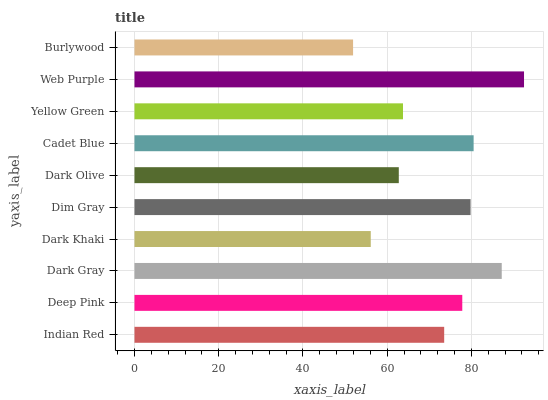Is Burlywood the minimum?
Answer yes or no. Yes. Is Web Purple the maximum?
Answer yes or no. Yes. Is Deep Pink the minimum?
Answer yes or no. No. Is Deep Pink the maximum?
Answer yes or no. No. Is Deep Pink greater than Indian Red?
Answer yes or no. Yes. Is Indian Red less than Deep Pink?
Answer yes or no. Yes. Is Indian Red greater than Deep Pink?
Answer yes or no. No. Is Deep Pink less than Indian Red?
Answer yes or no. No. Is Deep Pink the high median?
Answer yes or no. Yes. Is Indian Red the low median?
Answer yes or no. Yes. Is Indian Red the high median?
Answer yes or no. No. Is Dark Gray the low median?
Answer yes or no. No. 